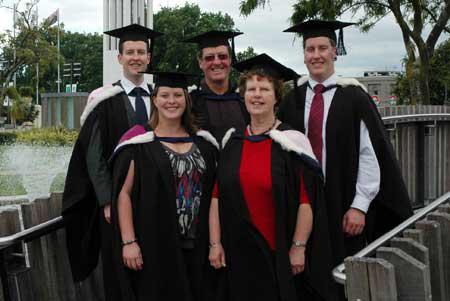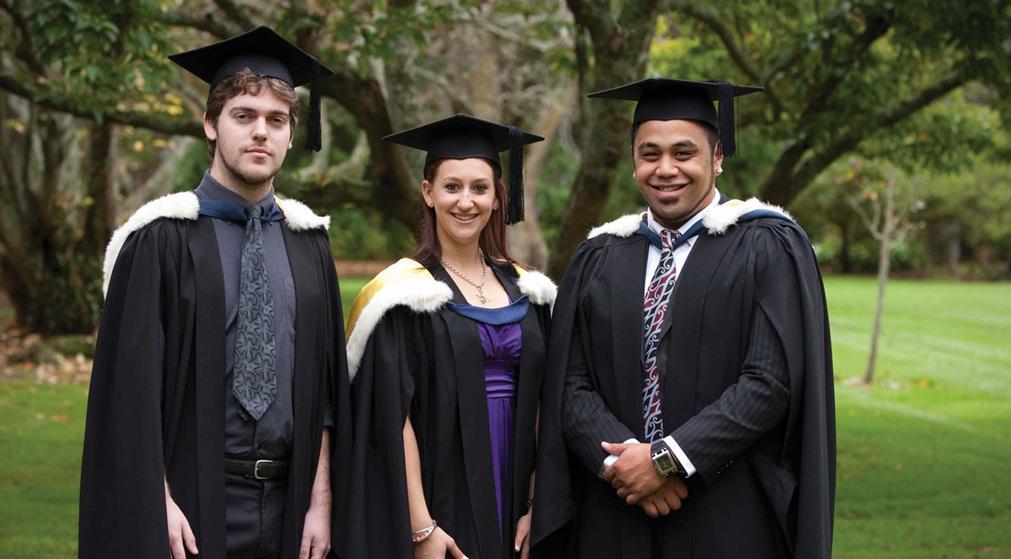The first image is the image on the left, the second image is the image on the right. Analyze the images presented: Is the assertion "The right image features graduates in black robes and caps, with blue and yellow balloons in the air." valid? Answer yes or no. No. The first image is the image on the left, the second image is the image on the right. For the images shown, is this caption "Several people stand in a single line outside in the grass in the image on the right." true? Answer yes or no. Yes. 